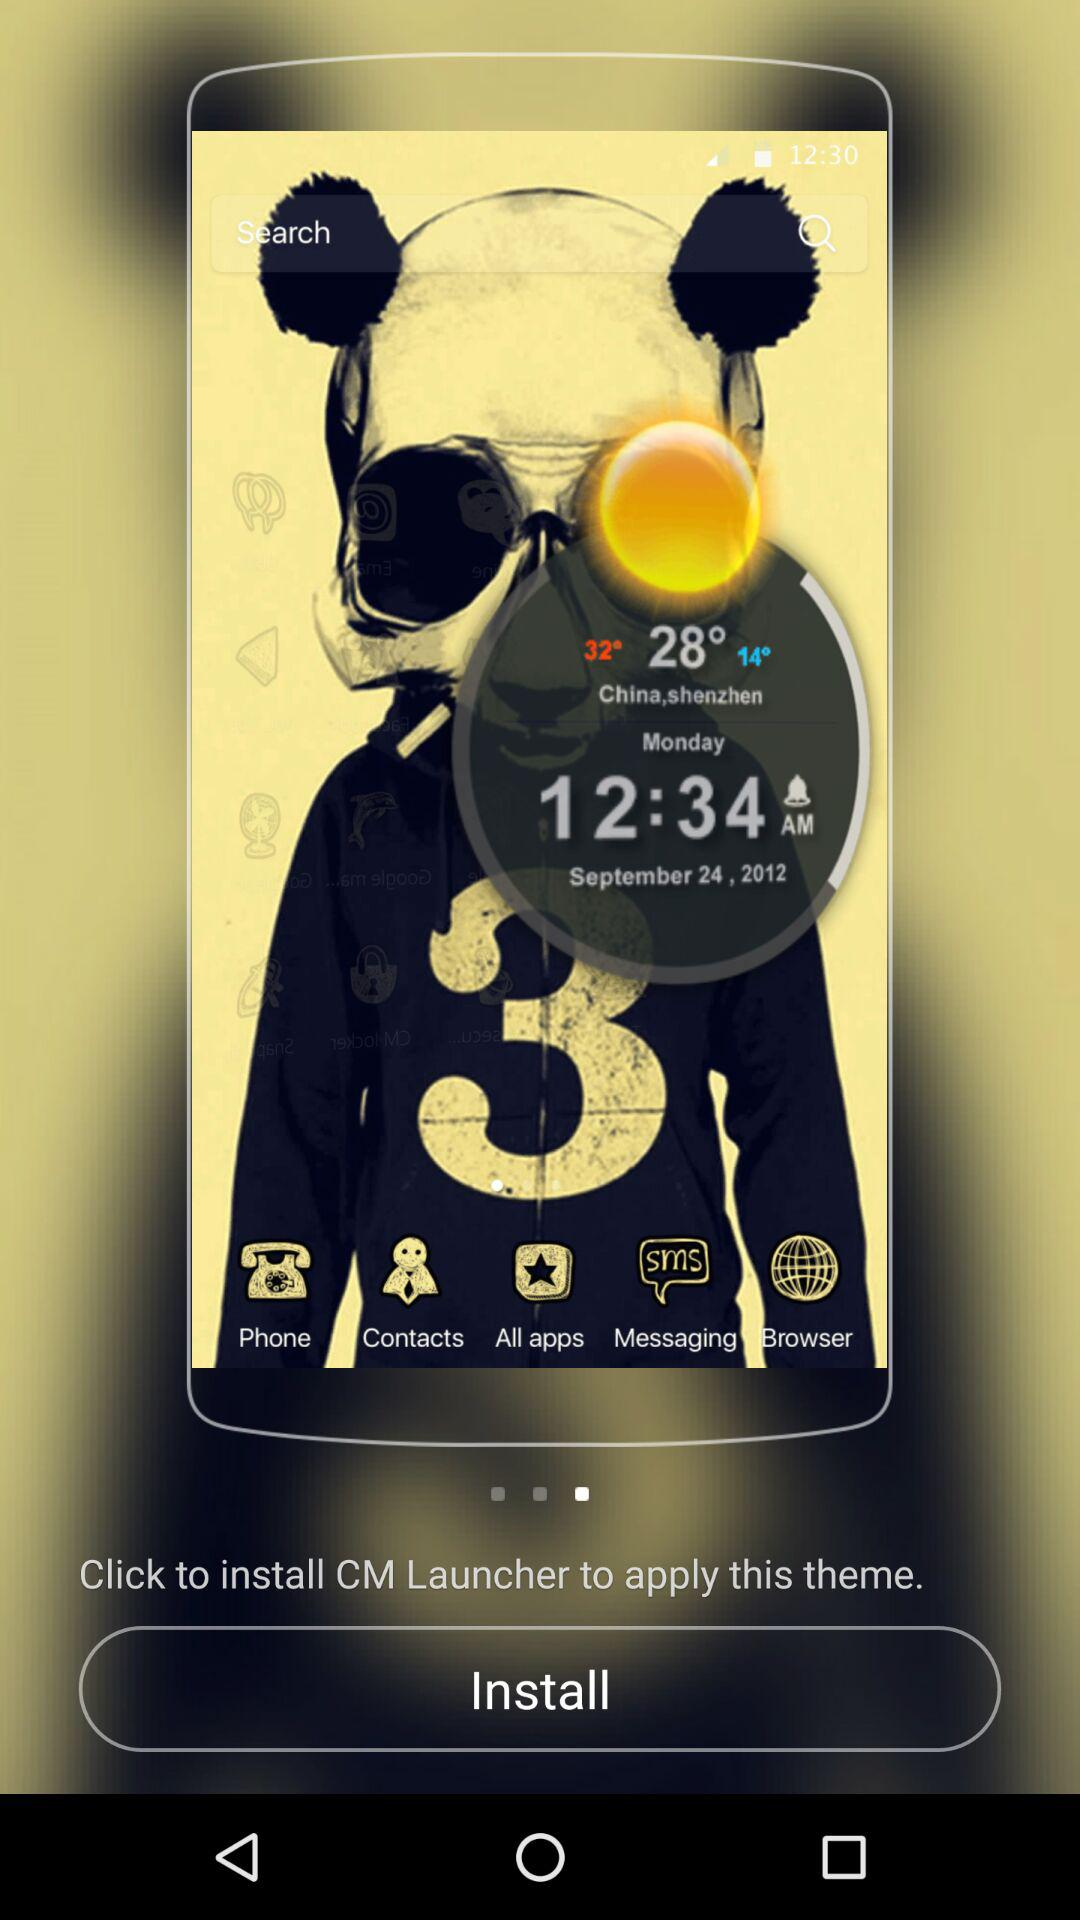What is the temperature currently in China, Shenzhen? The temperature is 28°. 